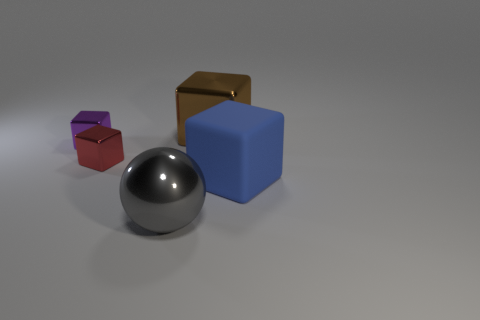Add 1 shiny cubes. How many objects exist? 6 Subtract all spheres. How many objects are left? 4 Add 4 blue blocks. How many blue blocks are left? 5 Add 2 large blue things. How many large blue things exist? 3 Subtract 0 blue spheres. How many objects are left? 5 Subtract all large blue rubber cylinders. Subtract all big brown metallic objects. How many objects are left? 4 